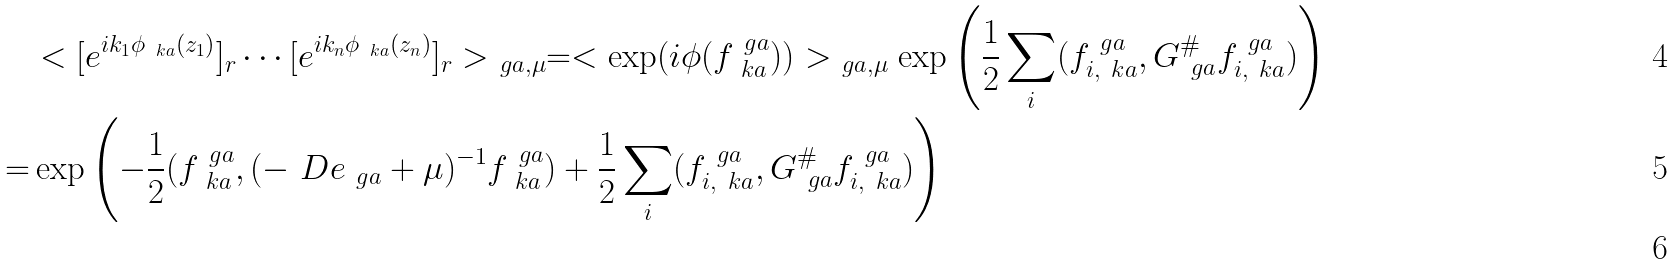Convert formula to latex. <formula><loc_0><loc_0><loc_500><loc_500>& < [ e ^ { i k _ { 1 } \phi _ { \ k a } ( z _ { 1 } ) } ] _ { r } \cdots [ e ^ { i k _ { n } \phi _ { \ k a } ( z _ { n } ) } ] _ { r } > _ { \ g a , \mu } = < \exp ( i \phi ( f ^ { \ g a } _ { \ k a } ) ) > _ { \ g a , \mu } \exp \left ( \frac { 1 } { 2 } \sum _ { i } ( f ^ { \ g a } _ { i , \ k a } , G ^ { \# } _ { \ g a } f ^ { \ g a } _ { i , \ k a } ) \right ) \\ = & \exp \left ( - \frac { 1 } { 2 } ( f ^ { \ g a } _ { \ k a } , ( - \ D e _ { \ g a } + \mu ) ^ { - 1 } f ^ { \ g a } _ { \ k a } ) + \frac { 1 } { 2 } \sum _ { i } ( f ^ { \ g a } _ { i , \ k a } , G ^ { \# } _ { \ g a } f ^ { \ g a } _ { i , \ k a } ) \right ) \\</formula> 